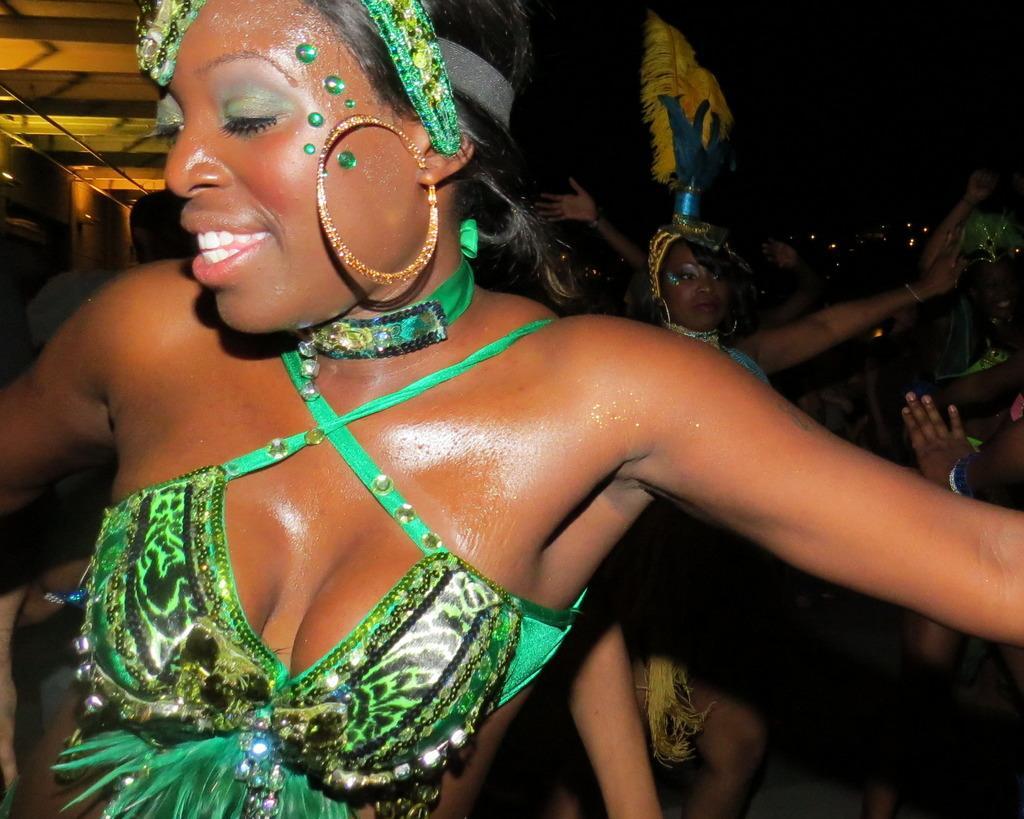How would you summarize this image in a sentence or two? In the image few ladies are dancing. They are wearing costume. In the background there is a building. 